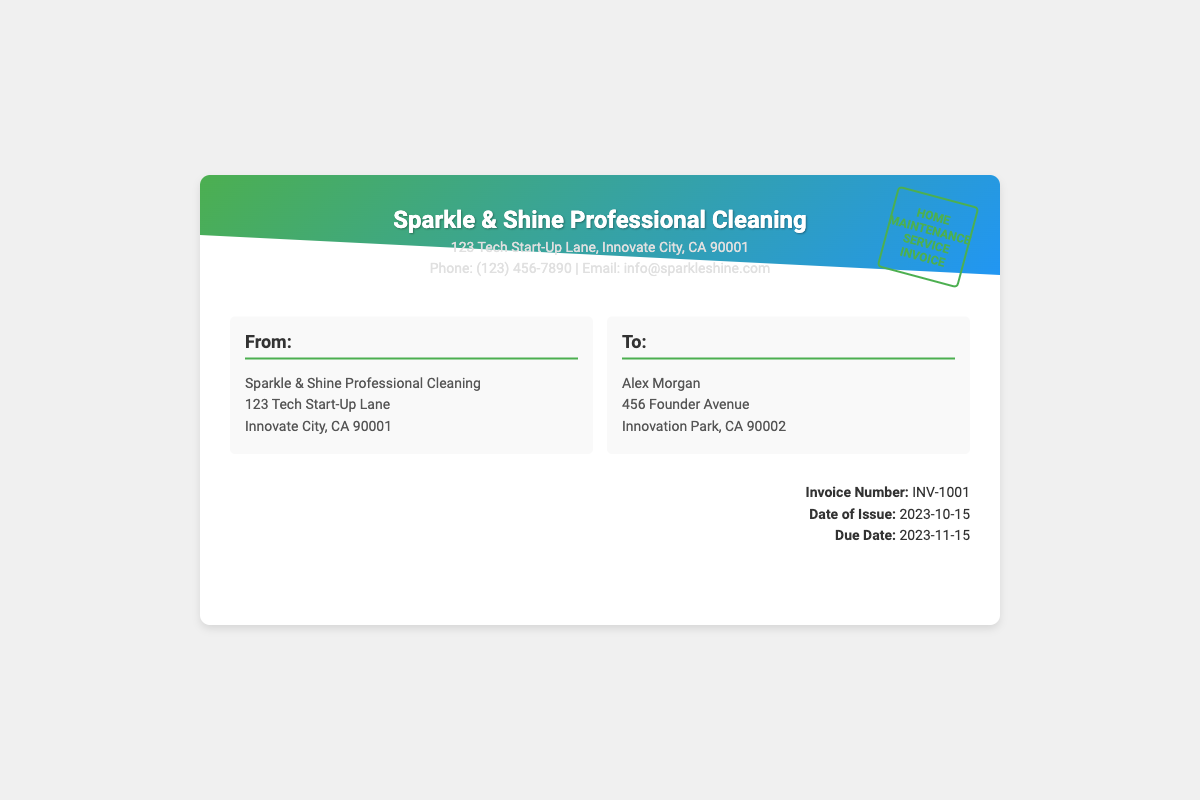what is the name of the cleaning service? The name of the cleaning service is prominently displayed in the header of the document.
Answer: Sparkle & Shine Professional Cleaning what is the invoice number? The invoice number is specified in the invoice details section.
Answer: INV-1001 who is the invoice addressed to? The recipient's name is listed in the "To:" section of the document.
Answer: Alex Morgan when is the due date for the invoice? The due date is mentioned in the invoice details section.
Answer: 2023-11-15 what is the address of the sender? The sender's address is found in the "From:" section of the document.
Answer: 123 Tech Start-Up Lane, Innovate City, CA 90001 how many days do I have to pay the invoice? The number of days between the date of issue and the due date indicates the payment period.
Answer: 31 days what gradient colors are used in the envelope design? The gradient colors used for the top section of the envelope provide visual appeal and branding.
Answer: Green and Blue what is the contact phone number for the cleaning service? The contact phone number is displayed in the header for easy reference.
Answer: (123) 456-7890 what type of service does this invoice represent? The stamp indicates the specific type of service related to the invoice.
Answer: Home Maintenance Service Invoice 